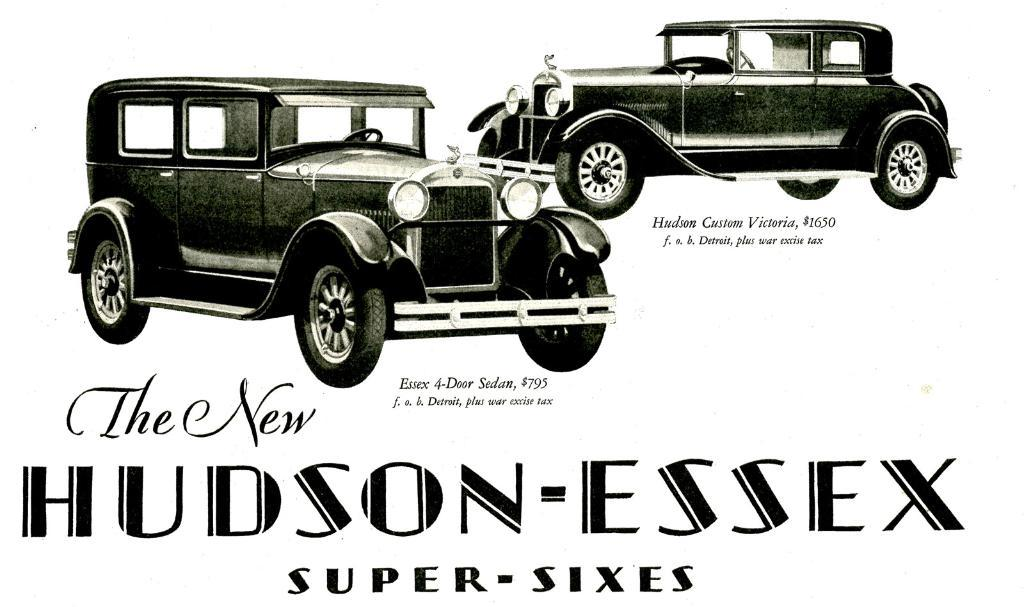What is the main subject of the image? The main subject of the image is a picture of cars. Where is the picture of cars located in the image? The picture of cars is at the top of the image. What else can be seen in the image besides the picture of cars? There is text written in the image. Where is the text located in the image? The text is located at the bottom of the image. What type of train can be seen passing by in the image? There is no train present in the image; it features a picture of cars and text. 